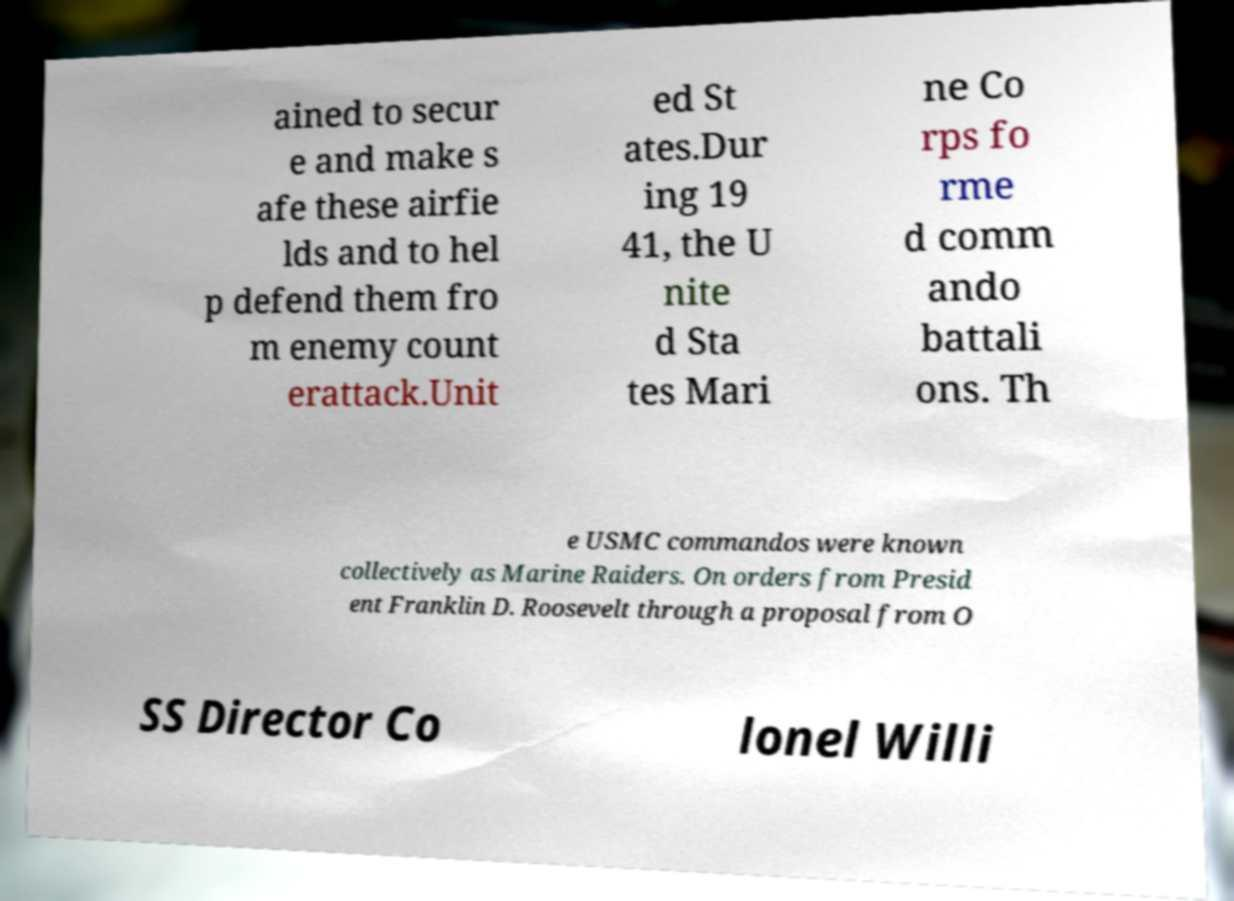Can you read and provide the text displayed in the image?This photo seems to have some interesting text. Can you extract and type it out for me? ained to secur e and make s afe these airfie lds and to hel p defend them fro m enemy count erattack.Unit ed St ates.Dur ing 19 41, the U nite d Sta tes Mari ne Co rps fo rme d comm ando battali ons. Th e USMC commandos were known collectively as Marine Raiders. On orders from Presid ent Franklin D. Roosevelt through a proposal from O SS Director Co lonel Willi 